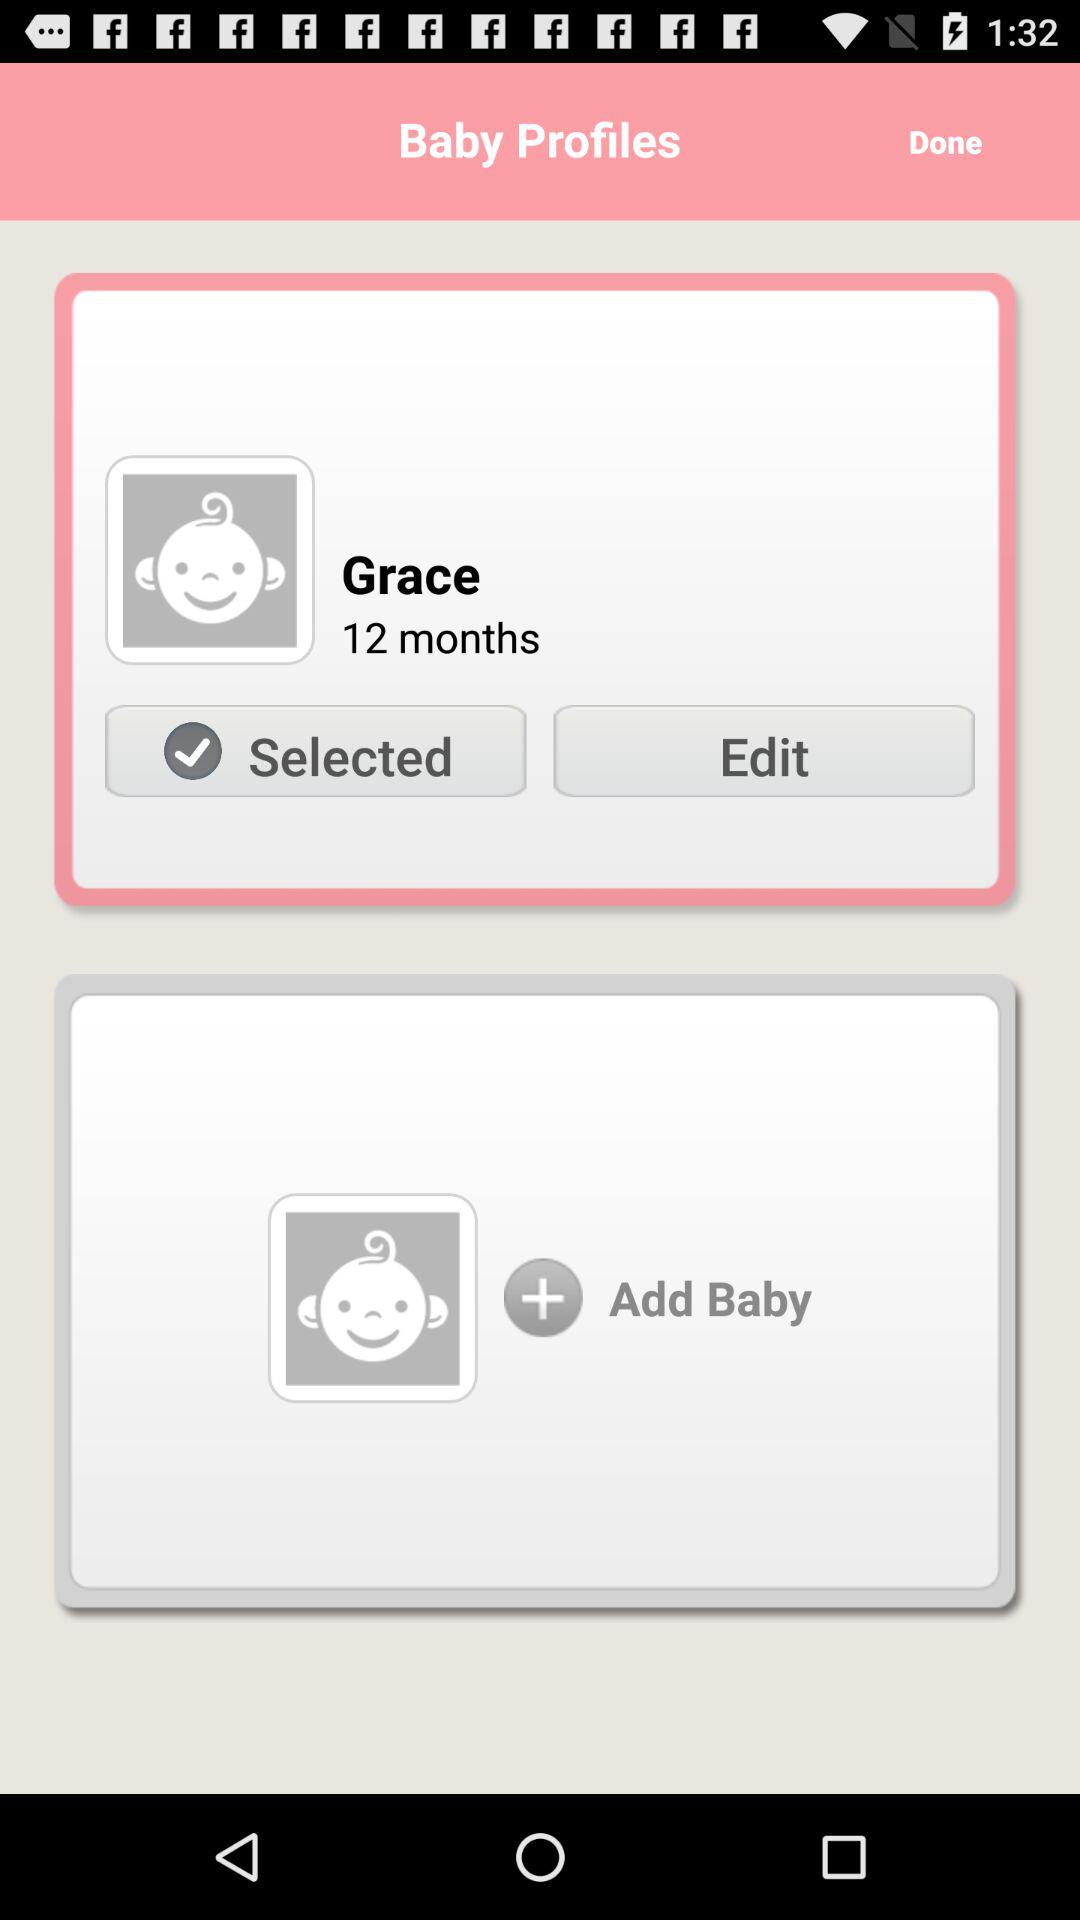What is the age of the user? The user is 12 months old. 